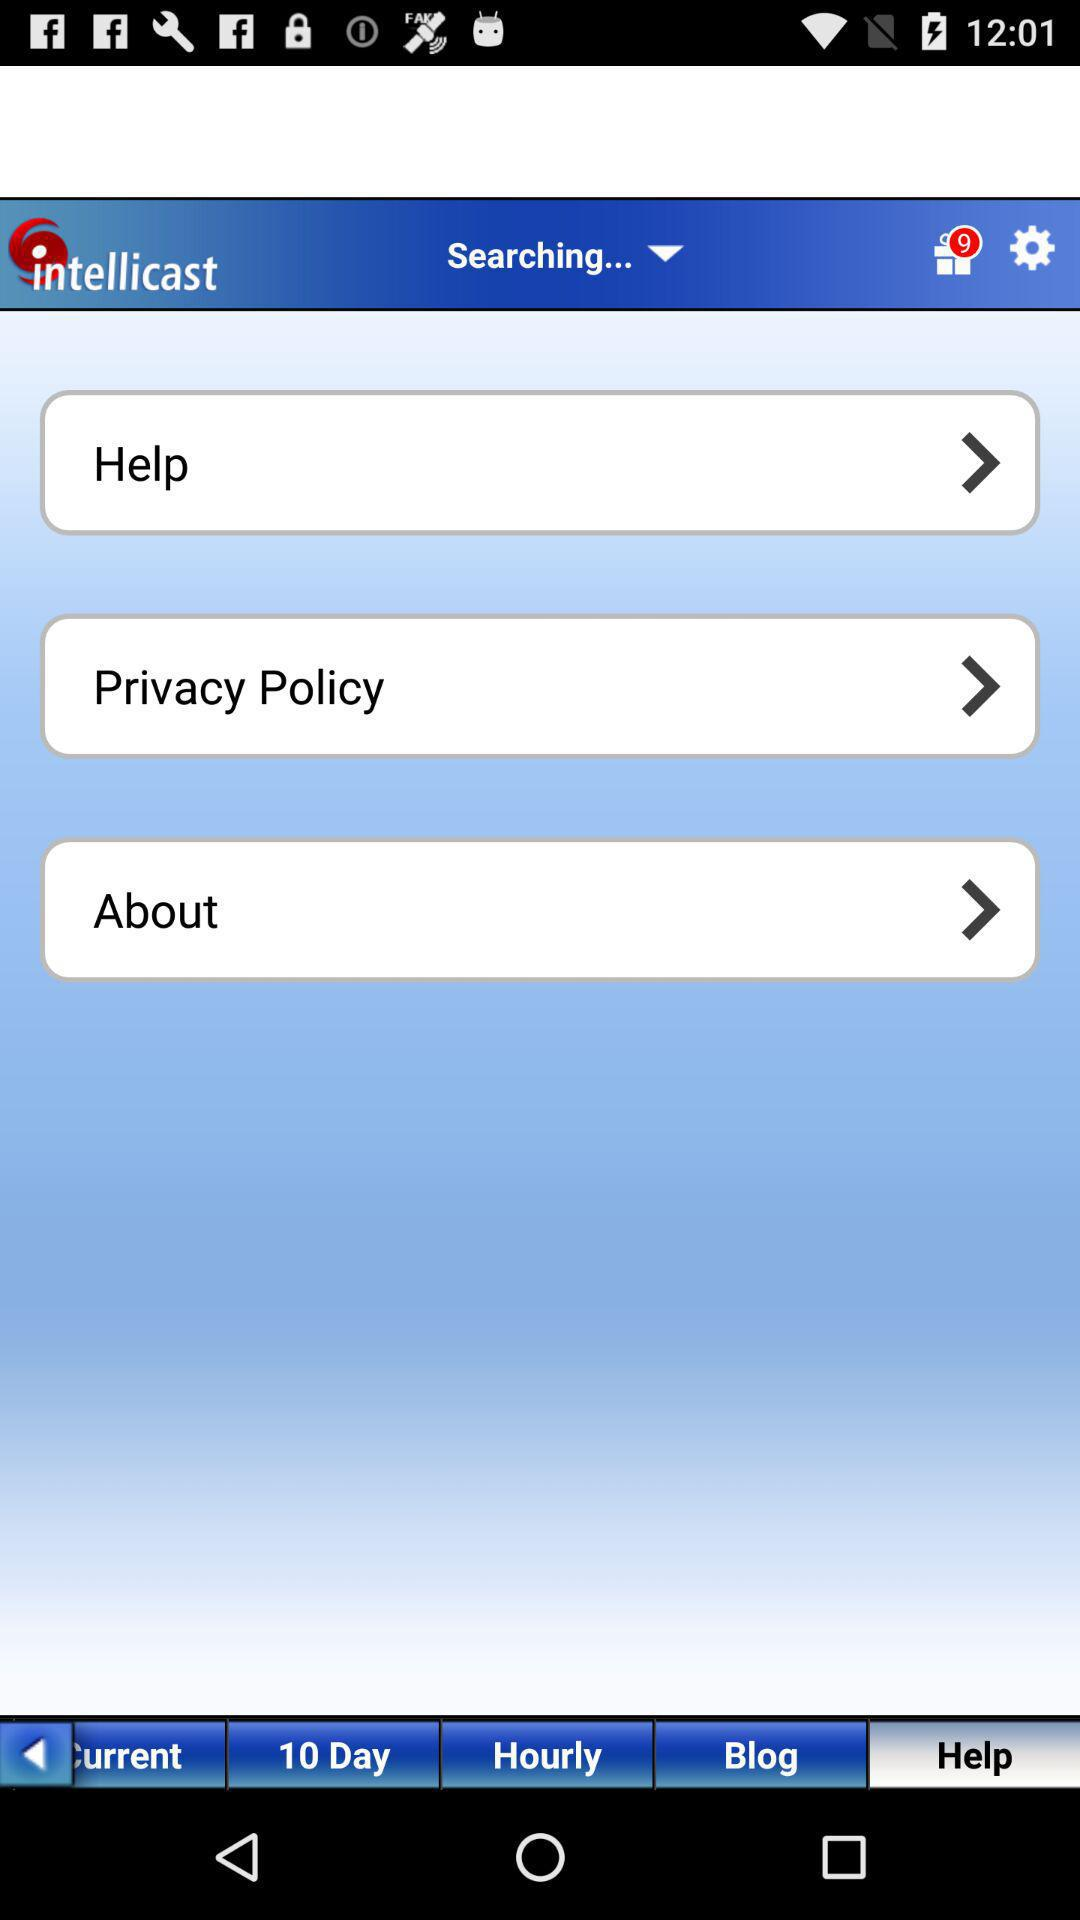Which tab has been selected? The selected tab is "Help". 